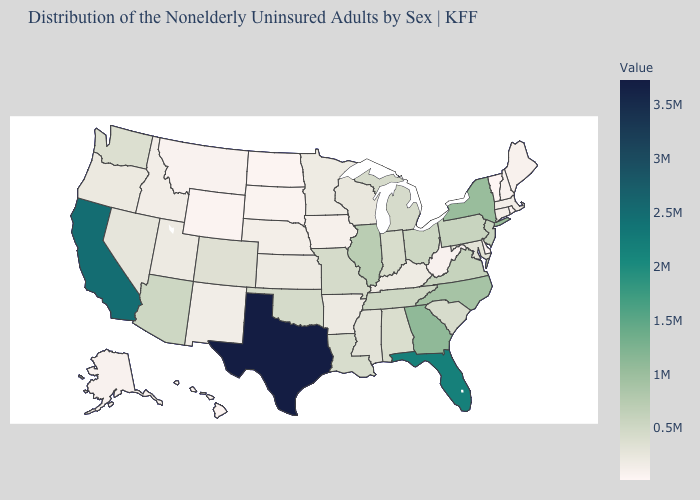Among the states that border Mississippi , does Alabama have the lowest value?
Give a very brief answer. No. Does Maine have a lower value than California?
Short answer required. Yes. Among the states that border Minnesota , does North Dakota have the lowest value?
Short answer required. Yes. Which states have the highest value in the USA?
Answer briefly. Texas. Which states hav the highest value in the West?
Give a very brief answer. California. Among the states that border West Virginia , which have the highest value?
Quick response, please. Virginia. Does California have the highest value in the West?
Be succinct. Yes. Does Hawaii have the lowest value in the West?
Concise answer only. Yes. Does North Dakota have the lowest value in the MidWest?
Be succinct. Yes. Which states have the highest value in the USA?
Write a very short answer. Texas. Among the states that border New Hampshire , which have the lowest value?
Quick response, please. Vermont. Which states have the highest value in the USA?
Be succinct. Texas. 